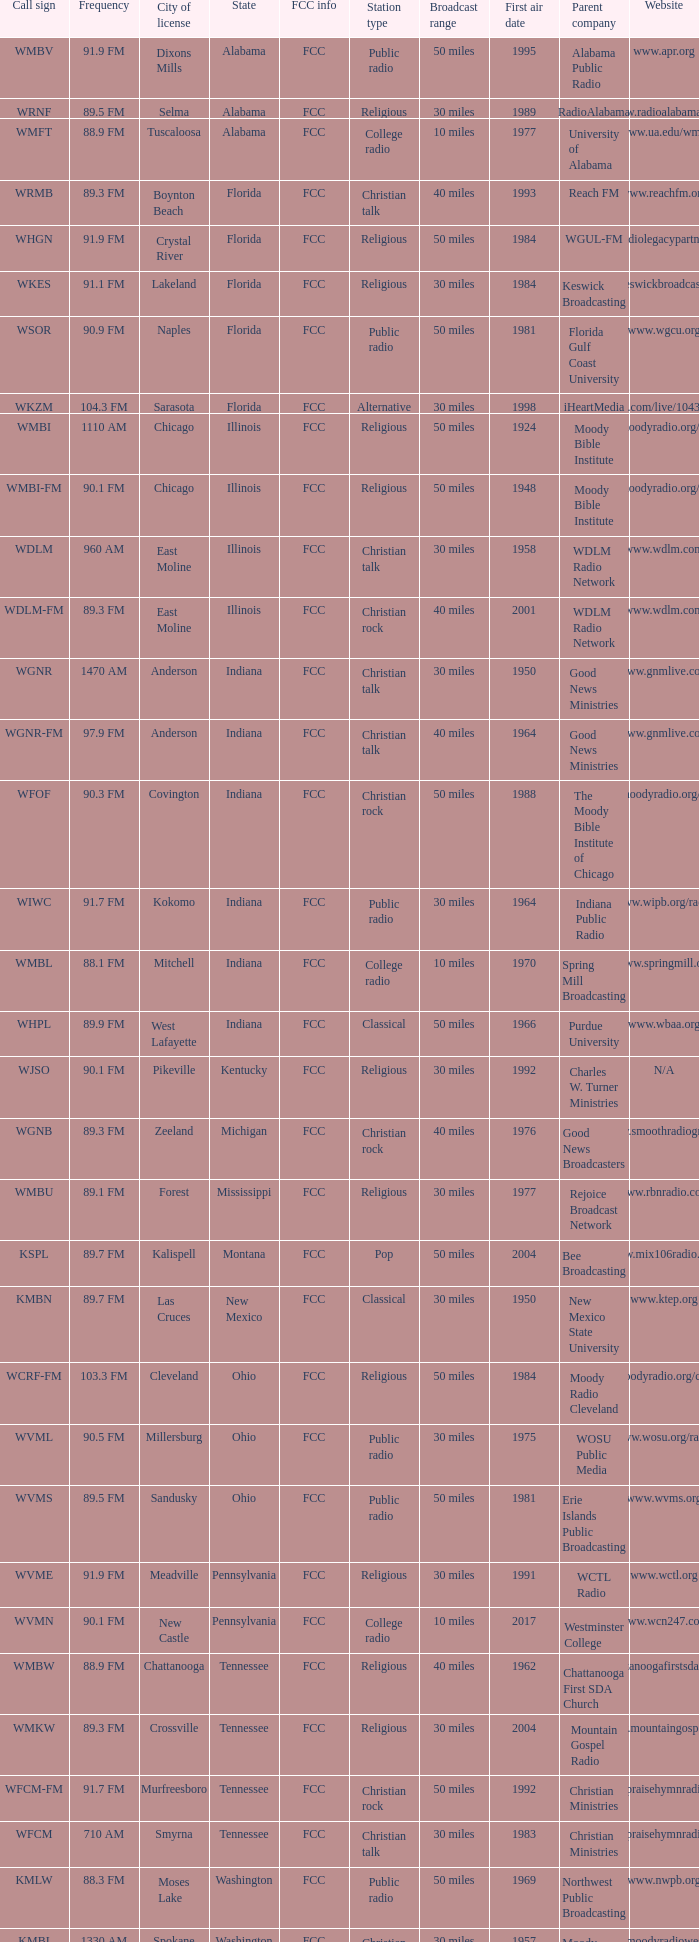What is the frequency of the radio station with a call sign of WGNR-FM? 97.9 FM. 